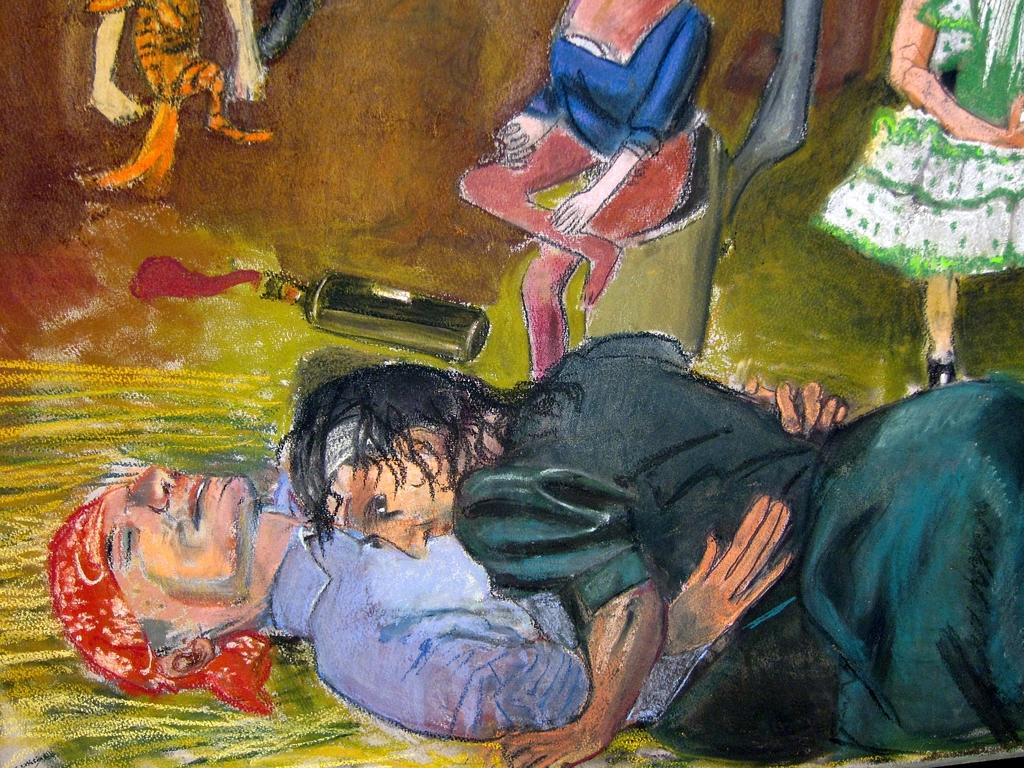What is the main subject of the image? The image contains an art piece. What does the art piece depict? The art piece depicts persons and a bottle. What type of popcorn can be seen in the art piece? There is no popcorn present in the art piece; it depicts persons and a bottle. How many balls are visible in the art piece? There are no balls visible in the art piece; it depicts persons and a bottle. 